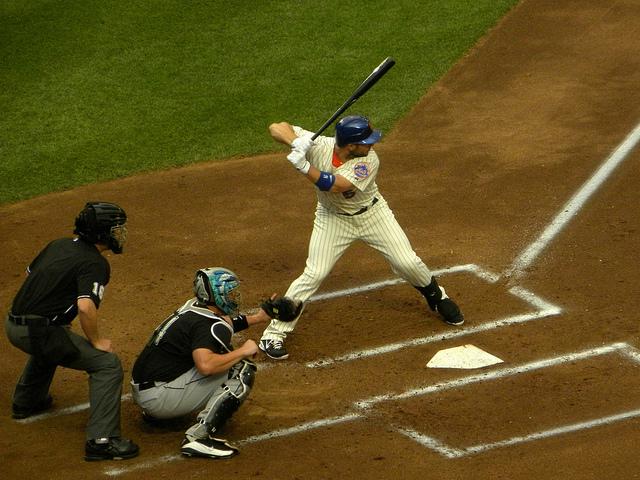What sport is this?
Be succinct. Baseball. Why there is dirt on the man to the right?
Give a very brief answer. Baseball field. Did the batter just hit the ball?
Write a very short answer. No. Who is the man crouched low?
Quick response, please. Catcher. Which sport is this?
Answer briefly. Baseball. Has this man already started swinging the bat?
Write a very short answer. No. 